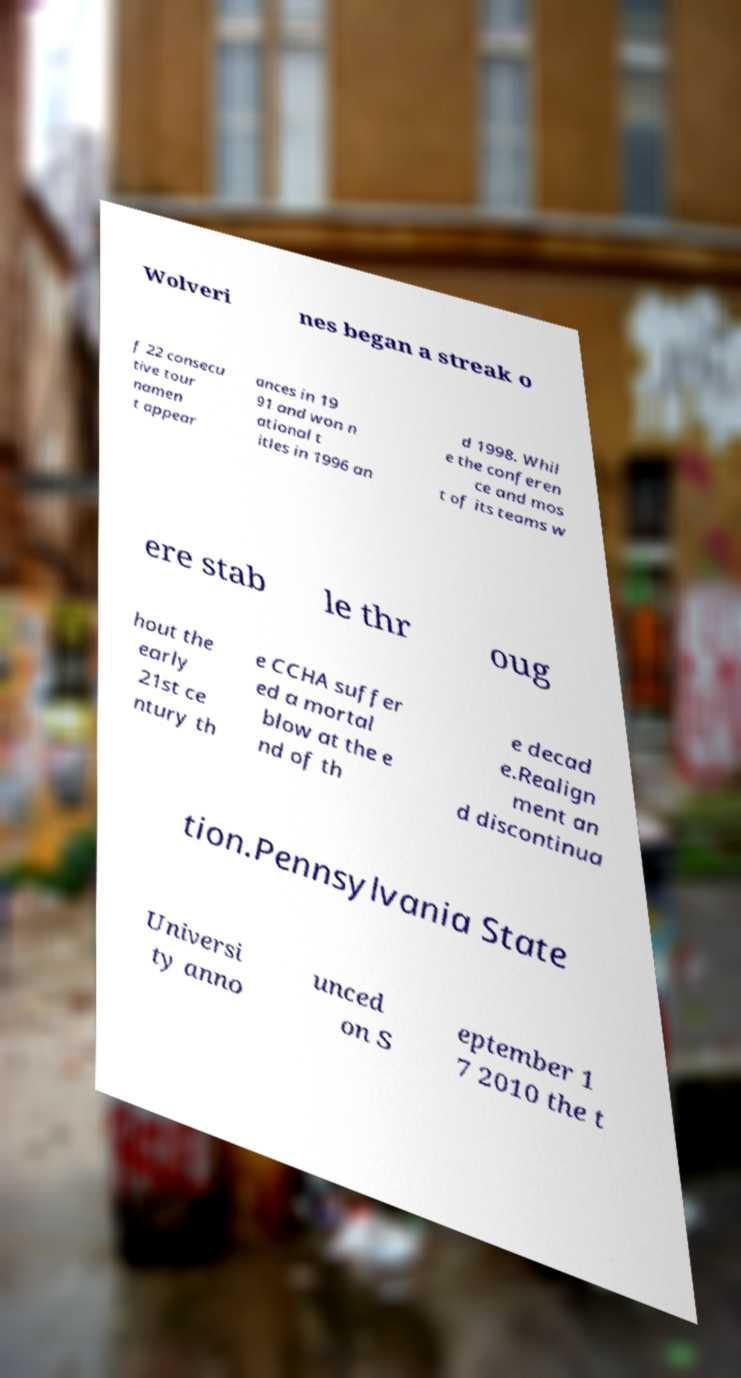I need the written content from this picture converted into text. Can you do that? Wolveri nes began a streak o f 22 consecu tive tour namen t appear ances in 19 91 and won n ational t itles in 1996 an d 1998. Whil e the conferen ce and mos t of its teams w ere stab le thr oug hout the early 21st ce ntury th e CCHA suffer ed a mortal blow at the e nd of th e decad e.Realign ment an d discontinua tion.Pennsylvania State Universi ty anno unced on S eptember 1 7 2010 the t 